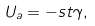Convert formula to latex. <formula><loc_0><loc_0><loc_500><loc_500>U _ { a } = - s t \gamma ,</formula> 